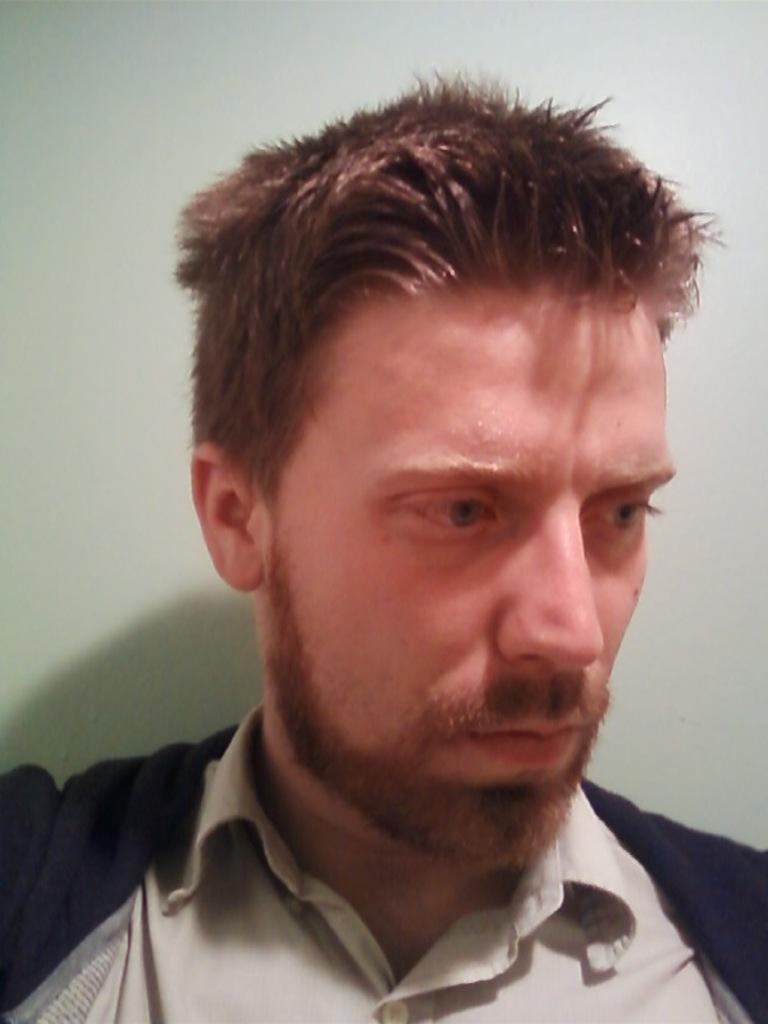Who is present in the image? There is a man in the image. What is the man wearing? The man is wearing a white and cream dress. What can be seen behind the man? There is a wall behind the man. What type of patch can be seen growing on the man's dress in the image? There is no patch visible on the man's dress in the image. 